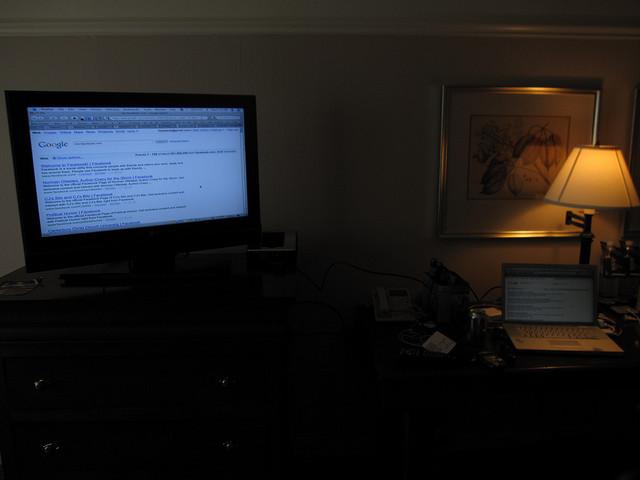Why aren't the walls black?
Be succinct. Paint. What is pictured on the monitor?
Be succinct. Google. Is there a light source in the photo that is not turned on?
Concise answer only. No. What color is the monitor?
Keep it brief. Black. What is plugged into the outlet?
Give a very brief answer. Computer. Can you see the whole television screen?
Quick response, please. Yes. What light source is causing the bright spot in this photograph?
Answer briefly. Lamp. What kind of device is this?
Answer briefly. Tv. Is it daytime?
Be succinct. No. What is hanging on the wall?
Quick response, please. Picture. Does the house looked lived in?
Keep it brief. Yes. What hand would the person operating this computer use to operate the mouse?
Concise answer only. Right. What kind of electronic is shown?
Keep it brief. Tv. Is the TV on?
Give a very brief answer. Yes. What is sitting in front of the TV?
Keep it brief. Dresser. What color are the walls?
Be succinct. White. Why should seasonings not be kept in this location?
Keep it brief. Not kitchen. Does the object inside the light change shapes?
Answer briefly. No. What is on the TV?
Short answer required. Google. What color is the scene on the television?
Concise answer only. White. Is the light on?
Write a very short answer. Yes. Is the screen on?
Write a very short answer. Yes. 